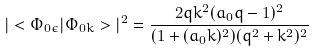<formula> <loc_0><loc_0><loc_500><loc_500>| < \Phi _ { 0 \epsilon } | \Phi _ { 0 k } > | ^ { 2 } = \frac { 2 q k ^ { 2 } ( a _ { 0 } q - 1 ) ^ { 2 } } { ( 1 + ( a _ { 0 } k ) ^ { 2 } ) ( q ^ { 2 } + k ^ { 2 } ) ^ { 2 } }</formula> 